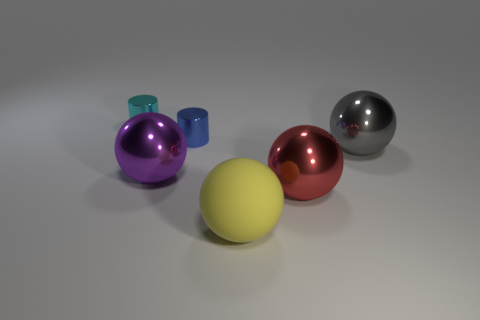Add 1 big brown rubber things. How many objects exist? 7 Subtract all large yellow matte spheres. How many spheres are left? 3 Subtract all red spheres. How many spheres are left? 3 Subtract 4 balls. How many balls are left? 0 Subtract all balls. How many objects are left? 2 Subtract all brown cylinders. Subtract all cyan cubes. How many cylinders are left? 2 Subtract all red spheres. How many cyan cylinders are left? 1 Subtract all large cyan shiny spheres. Subtract all big red objects. How many objects are left? 5 Add 2 cylinders. How many cylinders are left? 4 Add 3 small things. How many small things exist? 5 